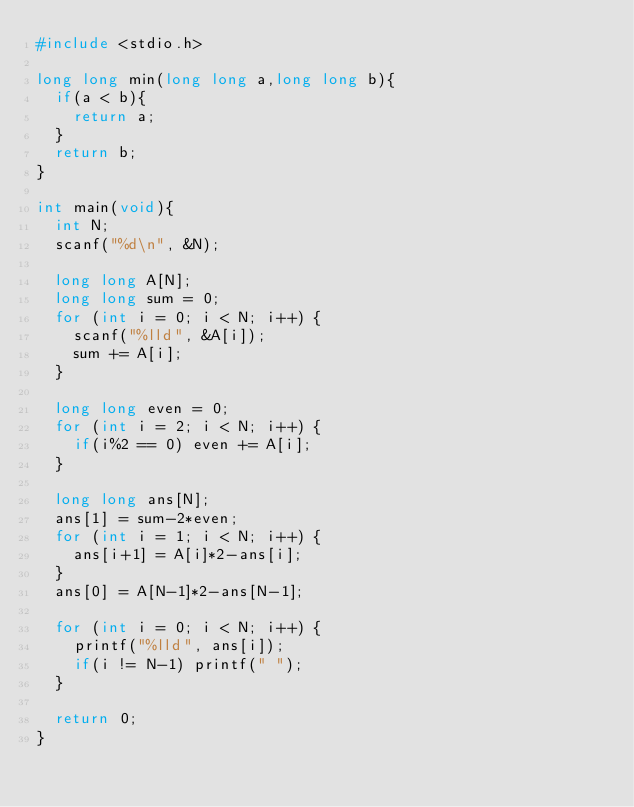<code> <loc_0><loc_0><loc_500><loc_500><_C_>#include <stdio.h>

long long min(long long a,long long b){
  if(a < b){
    return a;
  }
  return b;
}

int main(void){
  int N;
  scanf("%d\n", &N);

  long long A[N];
  long long sum = 0;
  for (int i = 0; i < N; i++) {
    scanf("%lld", &A[i]);
    sum += A[i];
  }

  long long even = 0;
  for (int i = 2; i < N; i++) {
    if(i%2 == 0) even += A[i];
  }

  long long ans[N];
  ans[1] = sum-2*even;
  for (int i = 1; i < N; i++) {
    ans[i+1] = A[i]*2-ans[i];
  }
  ans[0] = A[N-1]*2-ans[N-1];

  for (int i = 0; i < N; i++) {
    printf("%lld", ans[i]);
    if(i != N-1) printf(" ");
  }

  return 0;
}</code> 